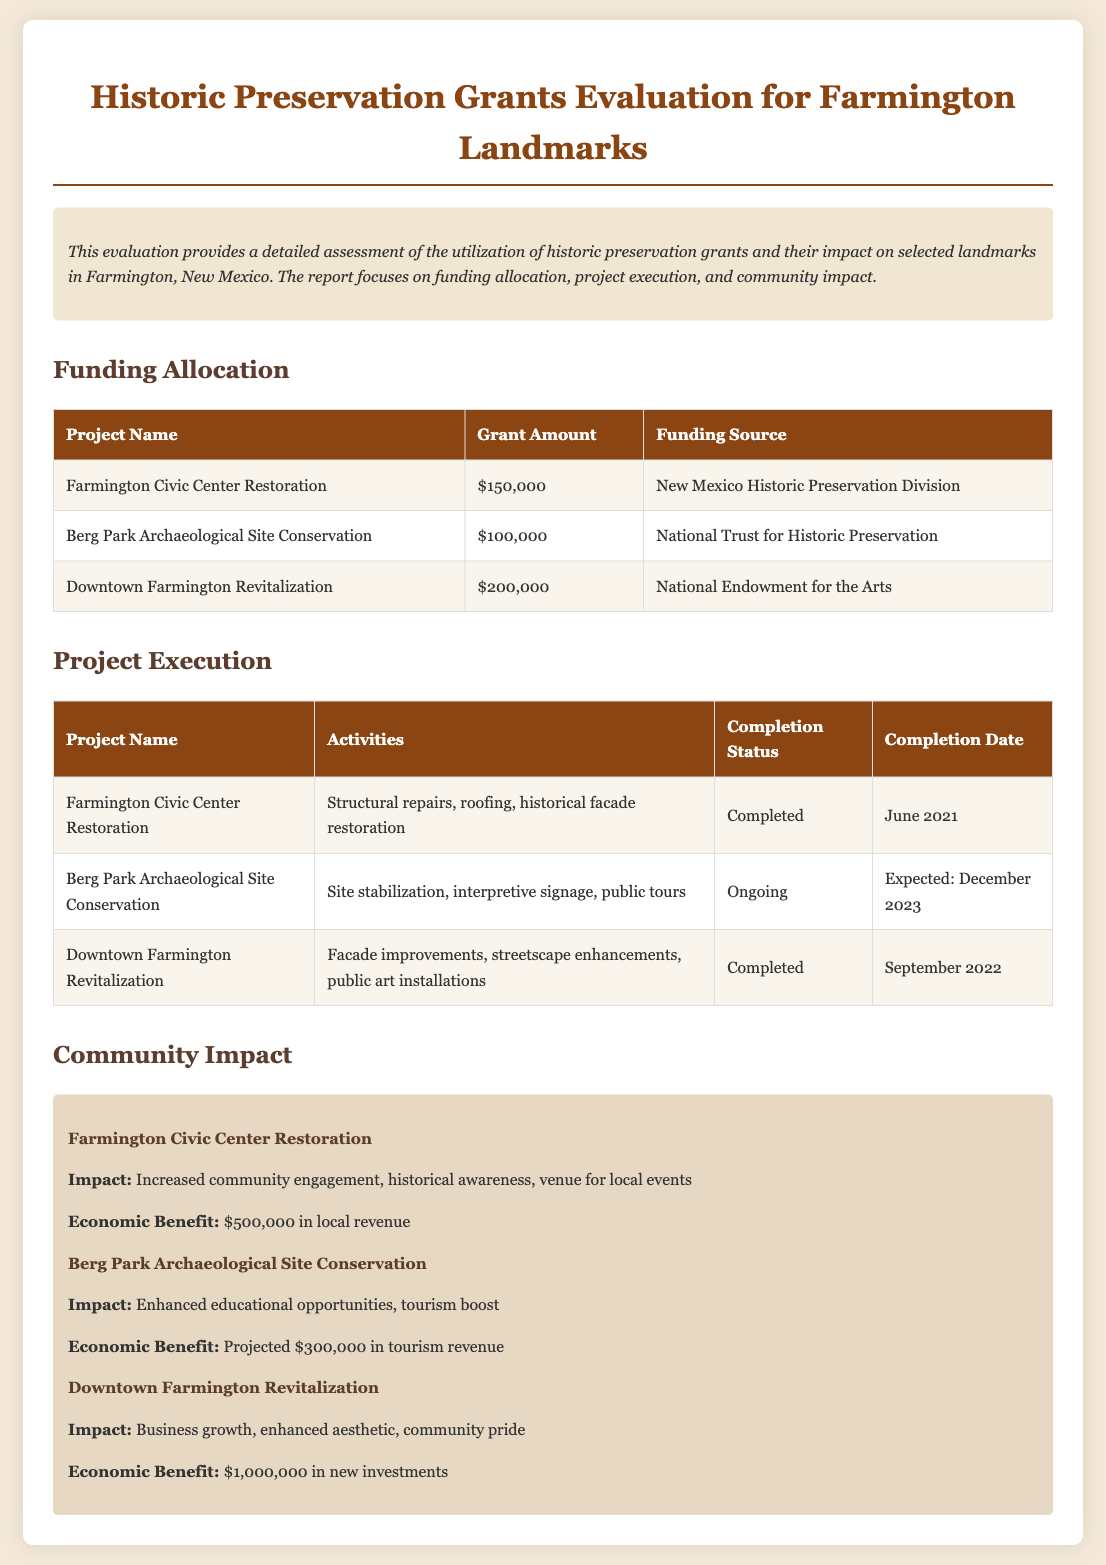What is the grant amount for the Farmington Civic Center Restoration? The document states that the grant amount for the Farmington Civic Center Restoration is $150,000.
Answer: $150,000 What is the completion status of the Berg Park Archaeological Site Conservation? According to the document, the completion status of the Berg Park Archaeological Site Conservation is ongoing.
Answer: Ongoing Which funding source provided money for the Downtown Farmington Revitalization? The document mentions that the funding source for the Downtown Farmington Revitalization is the National Endowment for the Arts.
Answer: National Endowment for the Arts What economic benefit is projected from the Berg Park Archaeological Site Conservation? The document indicates that the projected economic benefit from the Berg Park Archaeological Site Conservation is $300,000 in tourism revenue.
Answer: $300,000 What activities were conducted for the Downtown Farmington Revitalization? The document lists the activities for the Downtown Farmington Revitalization as facade improvements, streetscape enhancements, and public art installations.
Answer: Facade improvements, streetscape enhancements, public art installations Which project increased community engagement and historical awareness? The document outlines that the Farmington Civic Center Restoration increased community engagement and historical awareness.
Answer: Farmington Civic Center Restoration How much total grant funding was allocated across all projects listed? The total grant funding is calculated by adding $150,000, $100,000, and $200,000 from the three projects, resulting in $450,000.
Answer: $450,000 What completion date is expected for the Berg Park Archaeological Site Conservation? The document states that the expected completion date for the Berg Park Archaeological Site Conservation is December 2023.
Answer: December 2023 What is the community impact of the Downtown Farmington Revitalization? The document highlights business growth, enhanced aesthetic, and community pride as impacts of the Downtown Farmington Revitalization.
Answer: Business growth, enhanced aesthetic, community pride 